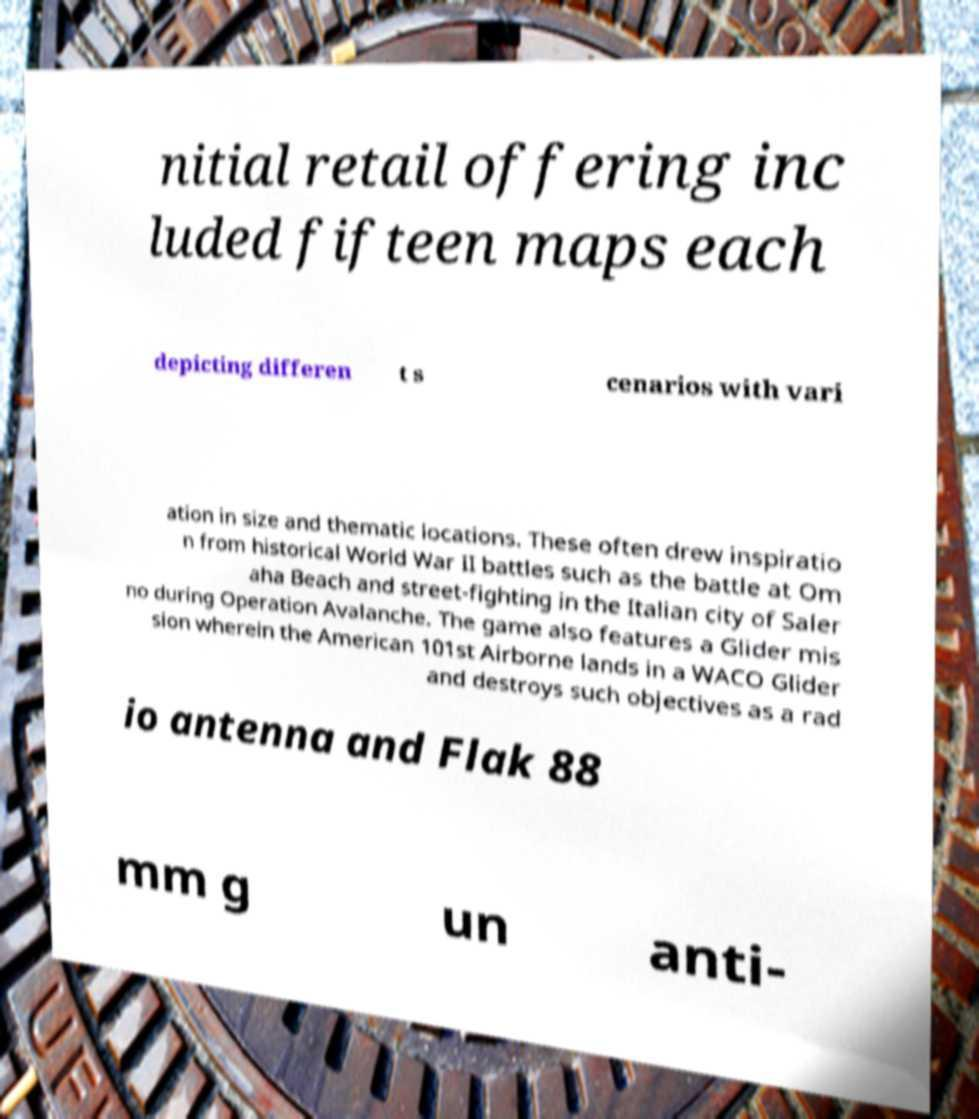I need the written content from this picture converted into text. Can you do that? nitial retail offering inc luded fifteen maps each depicting differen t s cenarios with vari ation in size and thematic locations. These often drew inspiratio n from historical World War II battles such as the battle at Om aha Beach and street-fighting in the Italian city of Saler no during Operation Avalanche. The game also features a Glider mis sion wherein the American 101st Airborne lands in a WACO Glider and destroys such objectives as a rad io antenna and Flak 88 mm g un anti- 